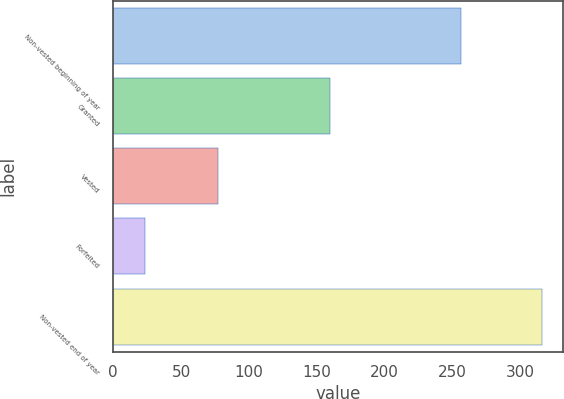Convert chart to OTSL. <chart><loc_0><loc_0><loc_500><loc_500><bar_chart><fcel>Non-vested beginning of year<fcel>Granted<fcel>Vested<fcel>Forfeited<fcel>Non-vested end of year<nl><fcel>256<fcel>160<fcel>77<fcel>23<fcel>316<nl></chart> 